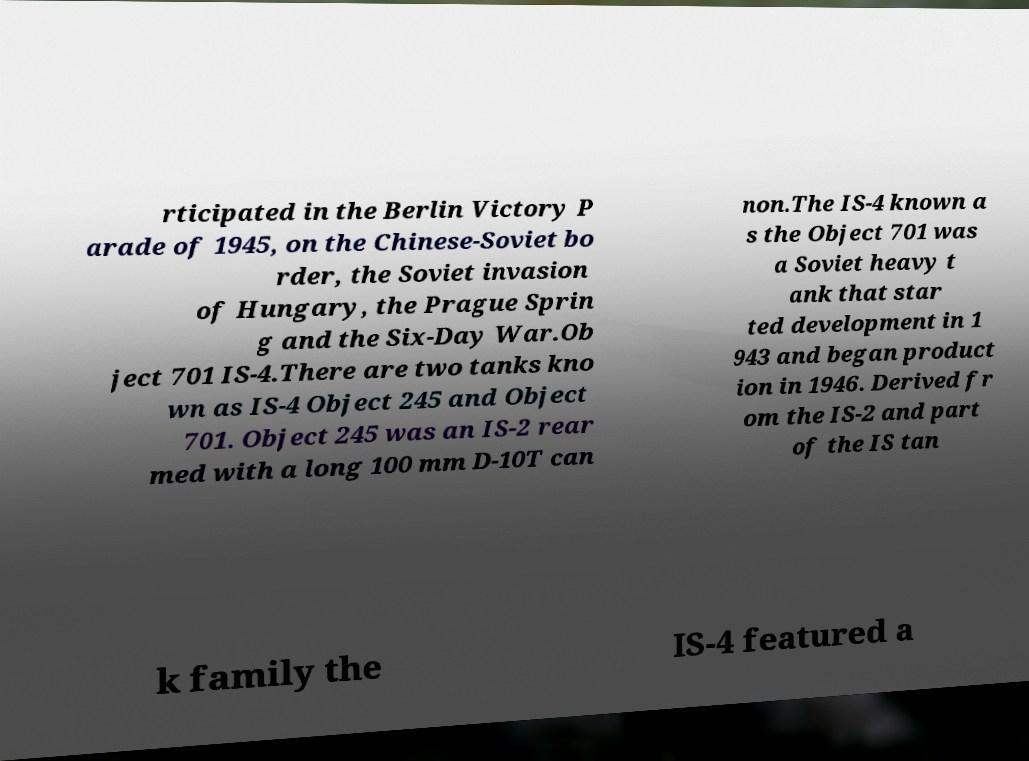Can you accurately transcribe the text from the provided image for me? rticipated in the Berlin Victory P arade of 1945, on the Chinese-Soviet bo rder, the Soviet invasion of Hungary, the Prague Sprin g and the Six-Day War.Ob ject 701 IS-4.There are two tanks kno wn as IS-4 Object 245 and Object 701. Object 245 was an IS-2 rear med with a long 100 mm D-10T can non.The IS-4 known a s the Object 701 was a Soviet heavy t ank that star ted development in 1 943 and began product ion in 1946. Derived fr om the IS-2 and part of the IS tan k family the IS-4 featured a 